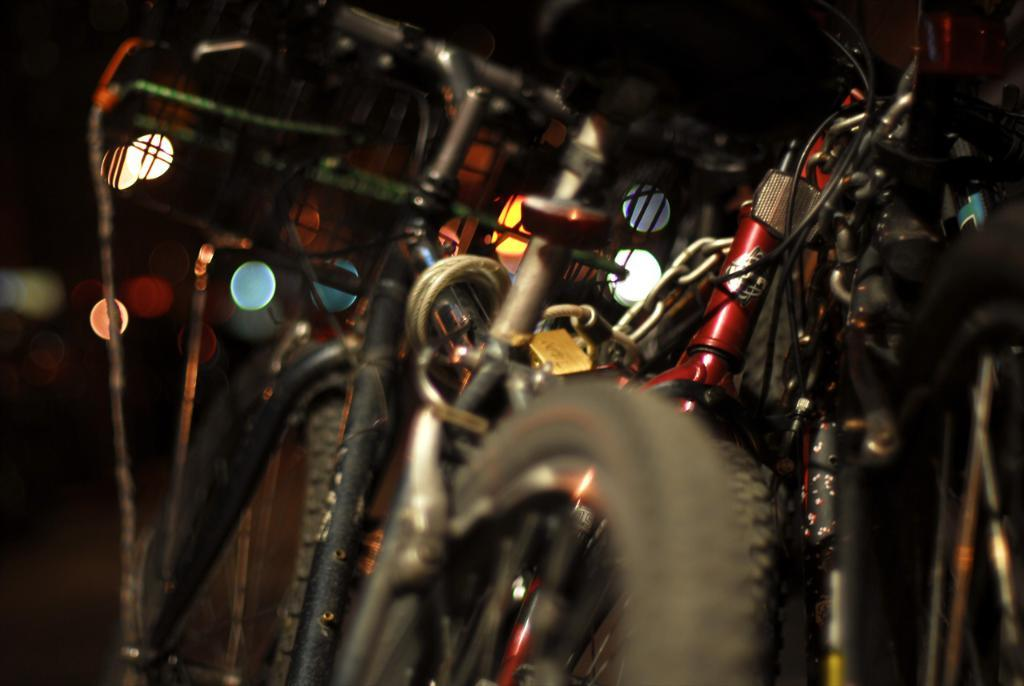What type of vehicles are in the image? There are bicycles in the image. Can you describe the background of the image? The background of the image is blurred. What type of note is being played by the plants in the image? There are no plants or musical notes present in the image; it only features bicycles and a blurred background. 